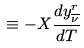Convert formula to latex. <formula><loc_0><loc_0><loc_500><loc_500>\equiv - X \frac { d y ^ { r } _ { \overline { \nu } } } { d T }</formula> 